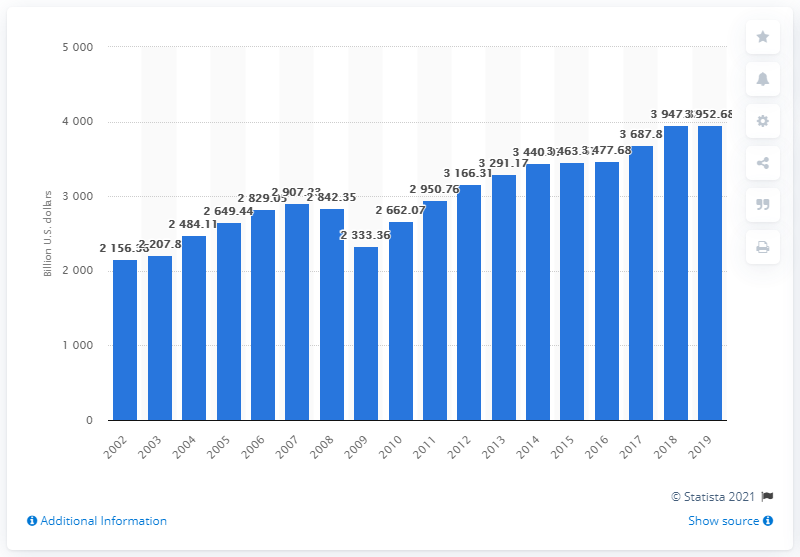Give some essential details in this illustration. In 2019, the total sales of durable goods by U.S. merchant wholesalers was 3952.68. 